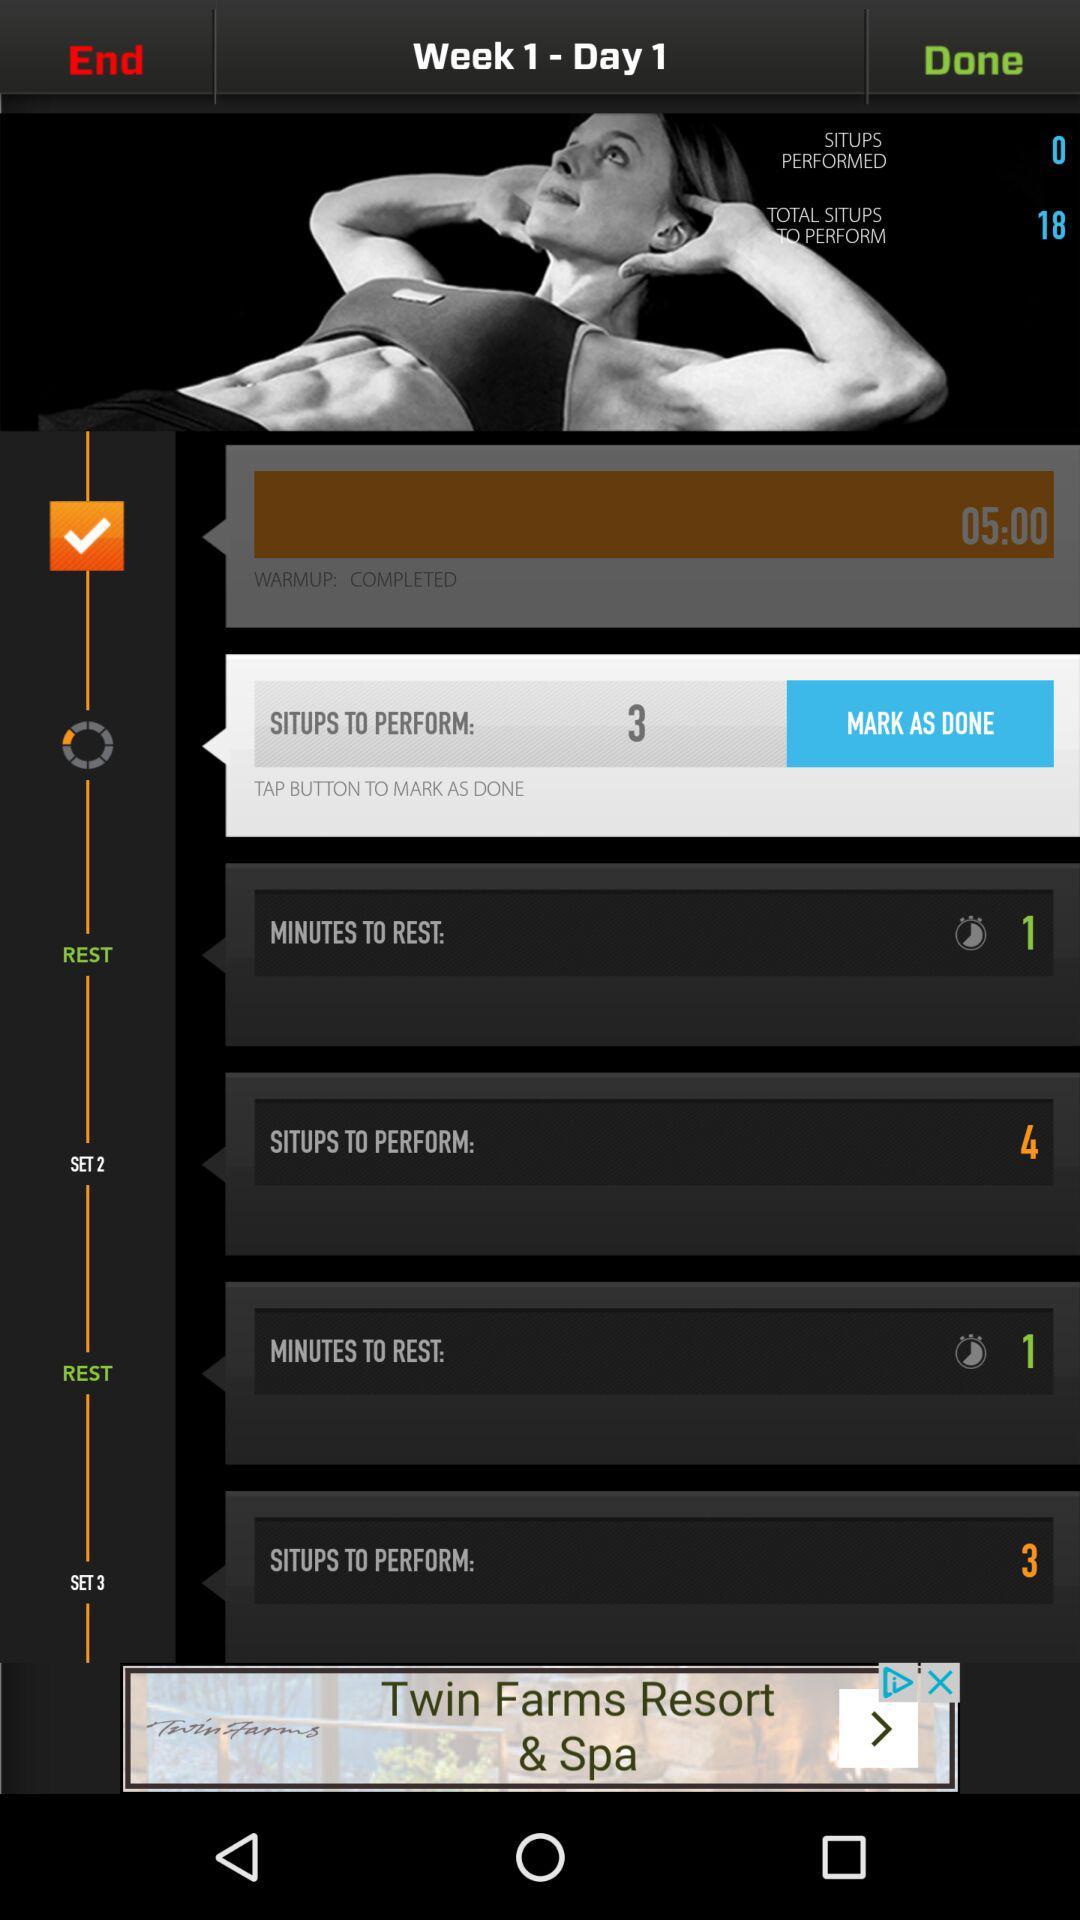How many minutes are there to rest? There is 1 minute to rest. 